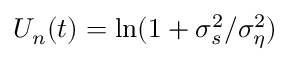<formula> <loc_0><loc_0><loc_500><loc_500>U _ { n } ( t ) = \ln ( 1 + \sigma _ { s } ^ { 2 } / \sigma _ { \eta } ^ { 2 } )</formula> 